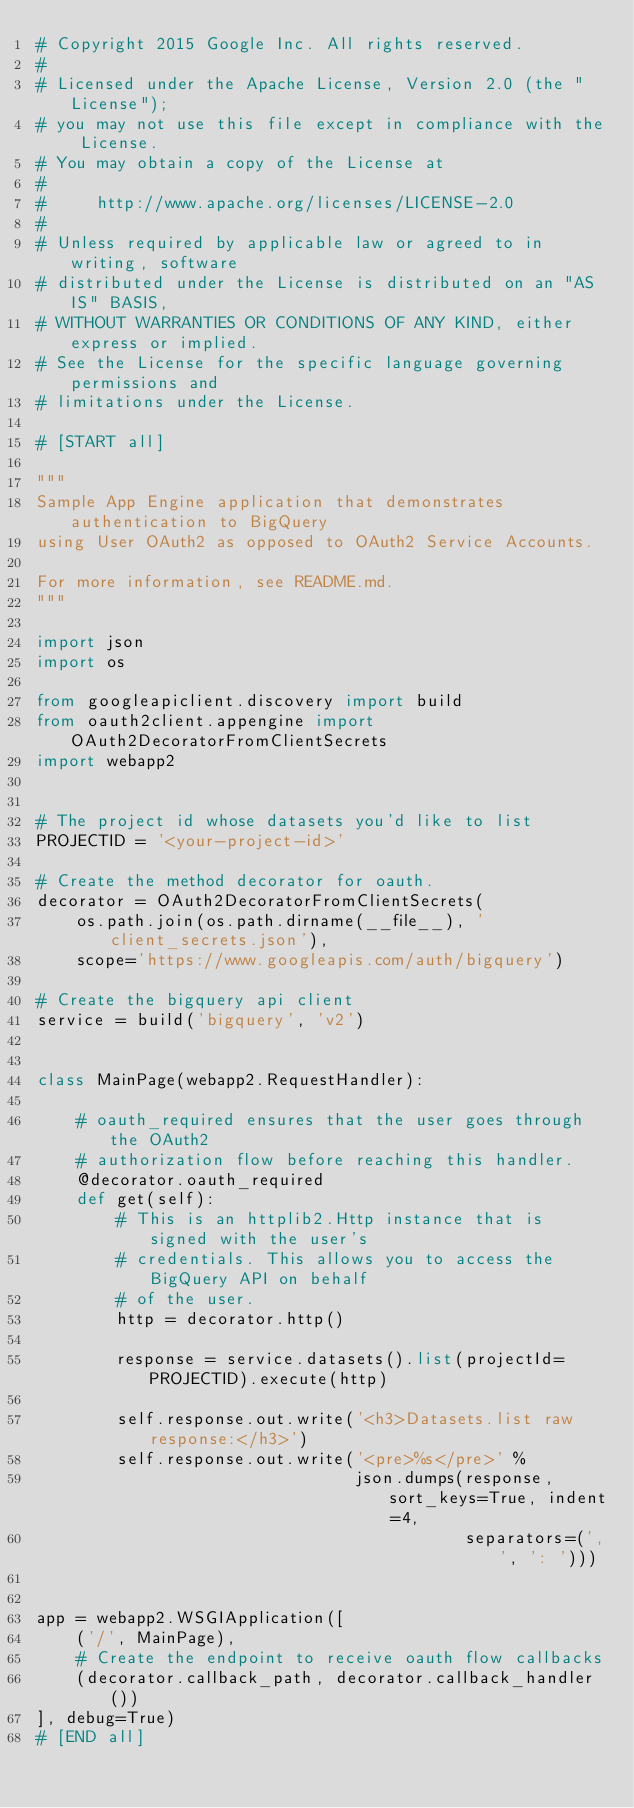<code> <loc_0><loc_0><loc_500><loc_500><_Python_># Copyright 2015 Google Inc. All rights reserved.
#
# Licensed under the Apache License, Version 2.0 (the "License");
# you may not use this file except in compliance with the License.
# You may obtain a copy of the License at
#
#     http://www.apache.org/licenses/LICENSE-2.0
#
# Unless required by applicable law or agreed to in writing, software
# distributed under the License is distributed on an "AS IS" BASIS,
# WITHOUT WARRANTIES OR CONDITIONS OF ANY KIND, either express or implied.
# See the License for the specific language governing permissions and
# limitations under the License.

# [START all]

"""
Sample App Engine application that demonstrates authentication to BigQuery
using User OAuth2 as opposed to OAuth2 Service Accounts.

For more information, see README.md.
"""

import json
import os

from googleapiclient.discovery import build
from oauth2client.appengine import OAuth2DecoratorFromClientSecrets
import webapp2


# The project id whose datasets you'd like to list
PROJECTID = '<your-project-id>'

# Create the method decorator for oauth.
decorator = OAuth2DecoratorFromClientSecrets(
    os.path.join(os.path.dirname(__file__), 'client_secrets.json'),
    scope='https://www.googleapis.com/auth/bigquery')

# Create the bigquery api client
service = build('bigquery', 'v2')


class MainPage(webapp2.RequestHandler):

    # oauth_required ensures that the user goes through the OAuth2
    # authorization flow before reaching this handler.
    @decorator.oauth_required
    def get(self):
        # This is an httplib2.Http instance that is signed with the user's
        # credentials. This allows you to access the BigQuery API on behalf
        # of the user.
        http = decorator.http()

        response = service.datasets().list(projectId=PROJECTID).execute(http)

        self.response.out.write('<h3>Datasets.list raw response:</h3>')
        self.response.out.write('<pre>%s</pre>' %
                                json.dumps(response, sort_keys=True, indent=4,
                                           separators=(',', ': ')))


app = webapp2.WSGIApplication([
    ('/', MainPage),
    # Create the endpoint to receive oauth flow callbacks
    (decorator.callback_path, decorator.callback_handler())
], debug=True)
# [END all]
</code> 